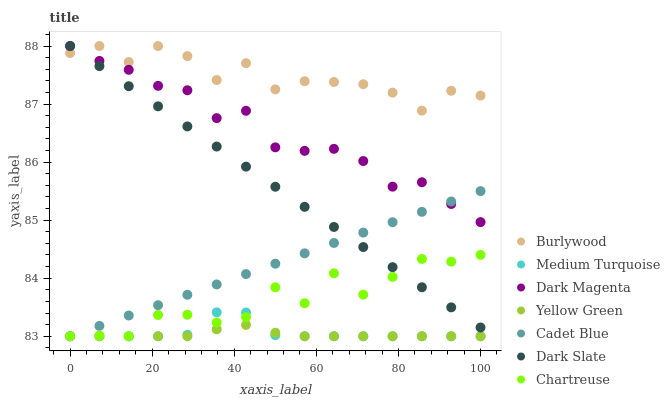Does Yellow Green have the minimum area under the curve?
Answer yes or no. Yes. Does Burlywood have the maximum area under the curve?
Answer yes or no. Yes. Does Dark Magenta have the minimum area under the curve?
Answer yes or no. No. Does Dark Magenta have the maximum area under the curve?
Answer yes or no. No. Is Cadet Blue the smoothest?
Answer yes or no. Yes. Is Burlywood the roughest?
Answer yes or no. Yes. Is Dark Magenta the smoothest?
Answer yes or no. No. Is Dark Magenta the roughest?
Answer yes or no. No. Does Cadet Blue have the lowest value?
Answer yes or no. Yes. Does Dark Magenta have the lowest value?
Answer yes or no. No. Does Dark Slate have the highest value?
Answer yes or no. Yes. Does Chartreuse have the highest value?
Answer yes or no. No. Is Yellow Green less than Dark Magenta?
Answer yes or no. Yes. Is Dark Magenta greater than Chartreuse?
Answer yes or no. Yes. Does Chartreuse intersect Medium Turquoise?
Answer yes or no. Yes. Is Chartreuse less than Medium Turquoise?
Answer yes or no. No. Is Chartreuse greater than Medium Turquoise?
Answer yes or no. No. Does Yellow Green intersect Dark Magenta?
Answer yes or no. No. 